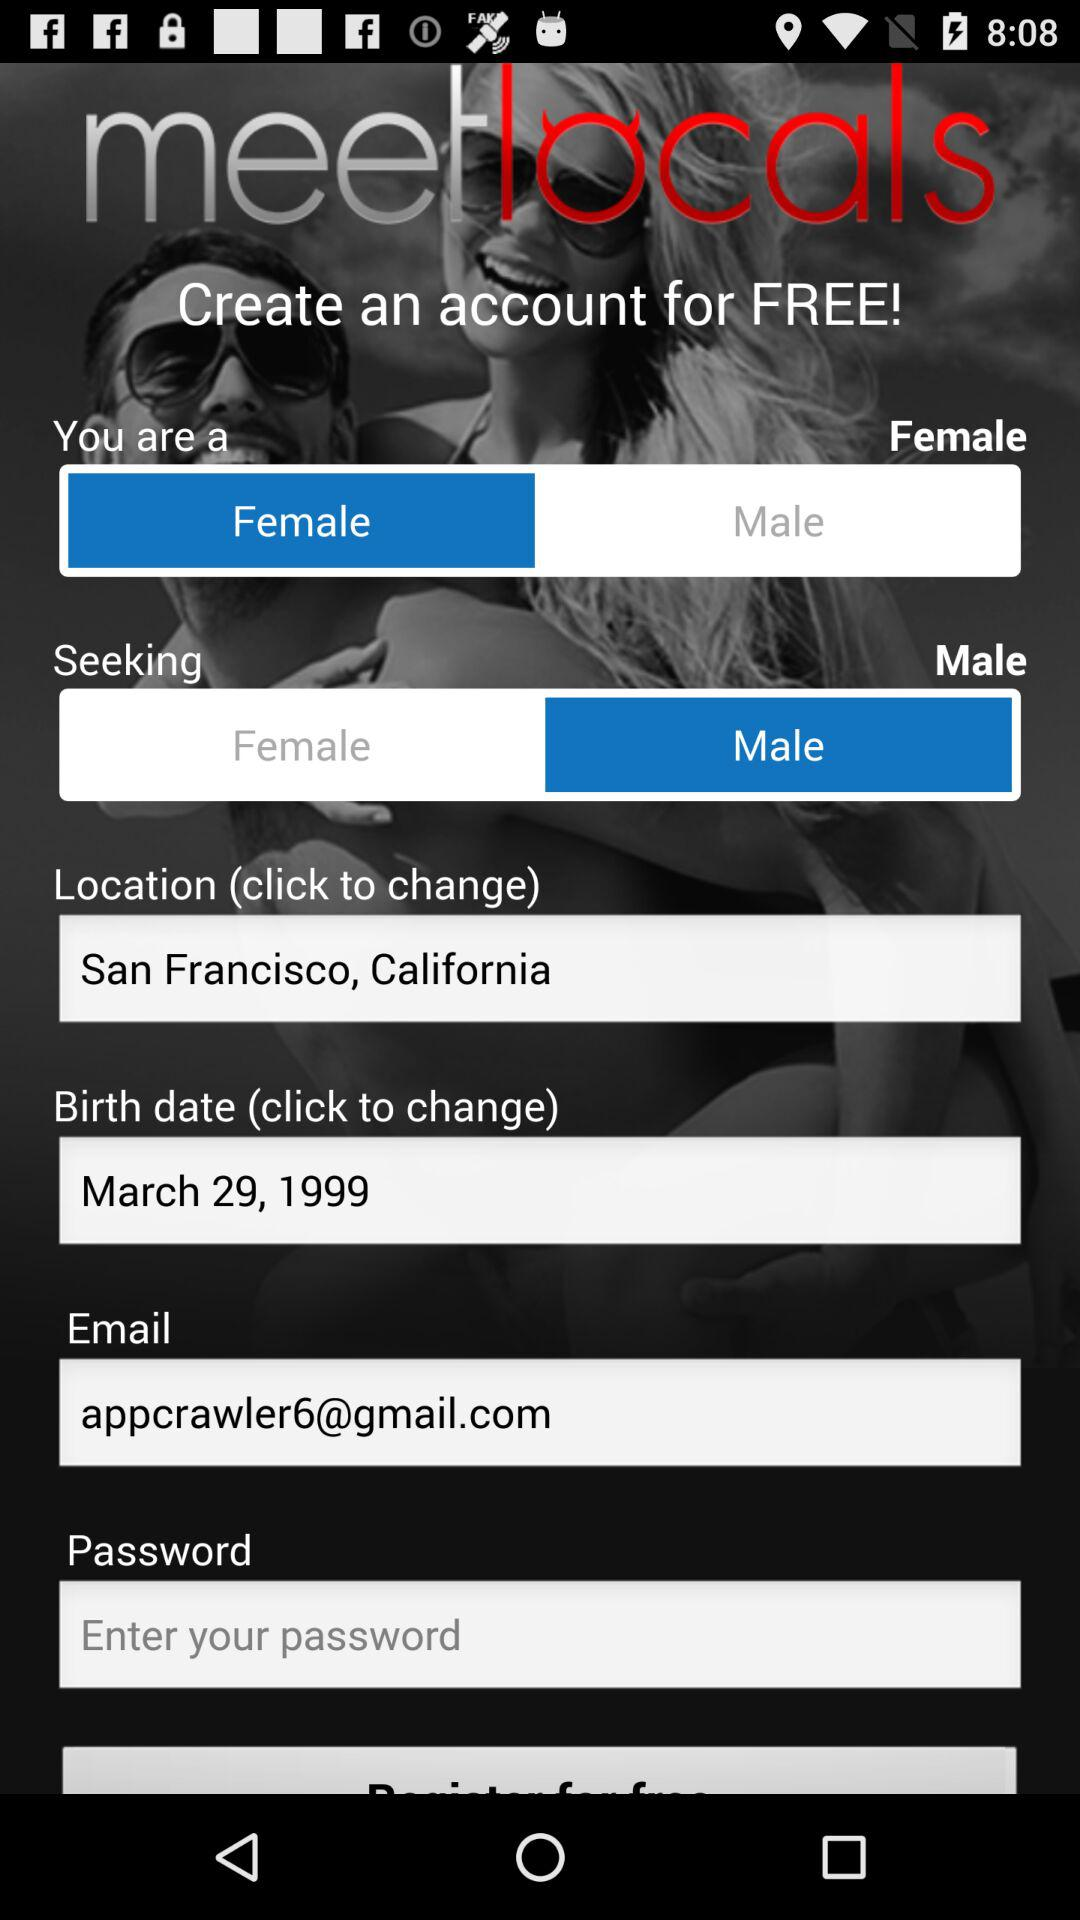What is the selected gender in "Seeking"? The selected gender in "Seeking" is male. 